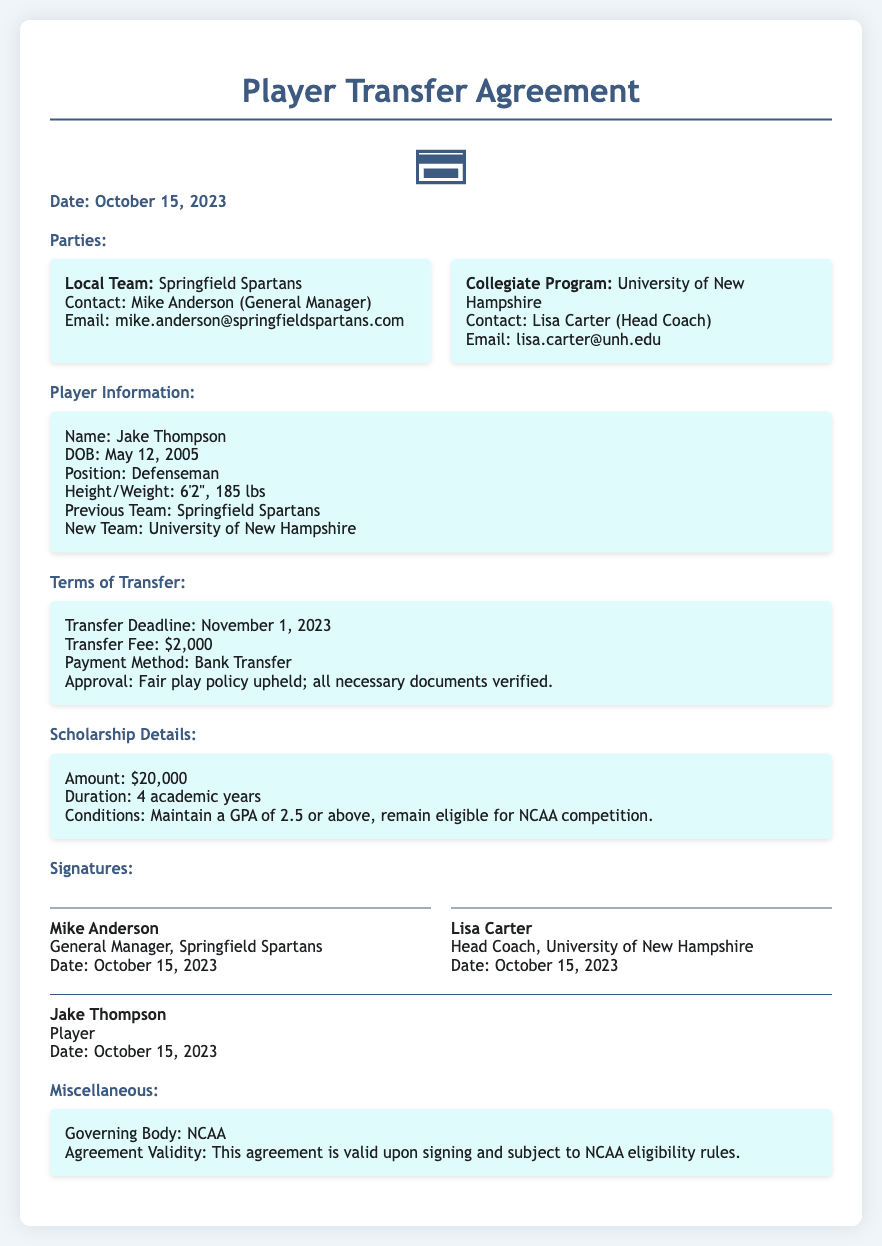What is the date of the agreement? The date of the agreement is mentioned at the top of the document.
Answer: October 15, 2023 Who is the General Manager of the local team? The General Manager's name and title are provided in the parties section.
Answer: Mike Anderson What is the transfer fee? The transfer fee is explicitly stated in the terms of transfer.
Answer: $2,000 What is the scholarship amount? The scholarship details section specifies the amount awarded.
Answer: $20,000 How long is the scholarship duration? This information is given in the scholarship details section.
Answer: 4 academic years What are the GPA conditions for the scholarship? The conditions for maintaining the scholarship are outlined in the scholarship details.
Answer: 2.5 or above Which team is Jake Thompson transferring from? The previous team of the player is mentioned in their information section.
Answer: Springfield Spartans Which governing body oversees this agreement? This detail is found in the miscellaneous section regarding validity.
Answer: NCAA What is the position of the player? The position is specified in the player information section.
Answer: Defenseman 